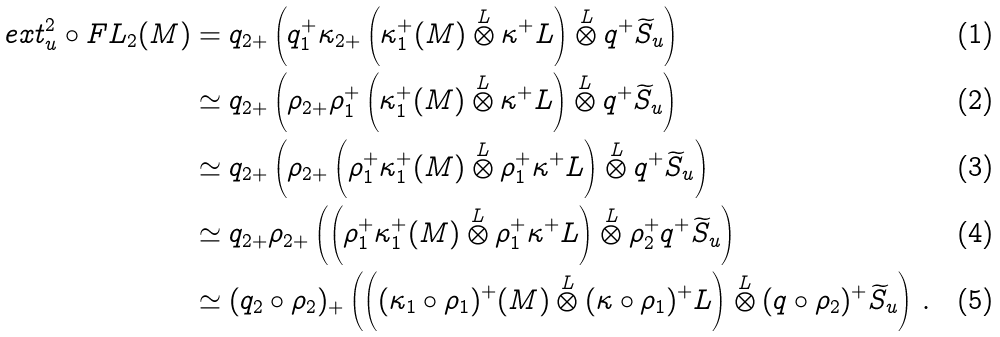<formula> <loc_0><loc_0><loc_500><loc_500>e x t _ { u } ^ { 2 } \circ F L _ { 2 } ( M ) & = q _ { 2 + } \left ( q _ { 1 } ^ { + } \kappa _ { 2 + } \left ( \kappa _ { 1 } ^ { + } ( M ) \overset { L } { \otimes } \kappa ^ { + } { L } \right ) \overset { L } { \otimes } q ^ { + } \widetilde { S } _ { u } \right ) \\ & \simeq q _ { 2 + } \left ( \rho _ { 2 + } \rho _ { 1 } ^ { + } \left ( \kappa _ { 1 } ^ { + } ( M ) \overset { L } { \otimes } \kappa ^ { + } { L } \right ) \overset { L } { \otimes } q ^ { + } \widetilde { S } _ { u } \right ) \\ & \simeq q _ { 2 + } \left ( \rho _ { 2 + } \left ( \rho _ { 1 } ^ { + } \kappa _ { 1 } ^ { + } ( M ) \overset { L } { \otimes } \rho _ { 1 } ^ { + } \kappa ^ { + } { L } \right ) \overset { L } { \otimes } q ^ { + } \widetilde { S } _ { u } \right ) \\ & \simeq q _ { 2 + } \rho _ { 2 + } \left ( \left ( \rho _ { 1 } ^ { + } \kappa _ { 1 } ^ { + } ( M ) \overset { L } { \otimes } \rho _ { 1 } ^ { + } \kappa ^ { + } { L } \right ) \overset { L } { \otimes } \rho _ { 2 } ^ { + } q ^ { + } \widetilde { S } _ { u } \right ) \\ & \simeq ( q _ { 2 } \circ \rho _ { 2 } ) _ { + } \left ( \left ( ( \kappa _ { 1 } \circ \rho _ { 1 } ) ^ { + } ( M ) \overset { L } { \otimes } ( \kappa \circ \rho _ { 1 } ) ^ { + } { L } \right ) \overset { L } { \otimes } ( q \circ \rho _ { 2 } ) ^ { + } \widetilde { S } _ { u } \right ) \, .</formula> 